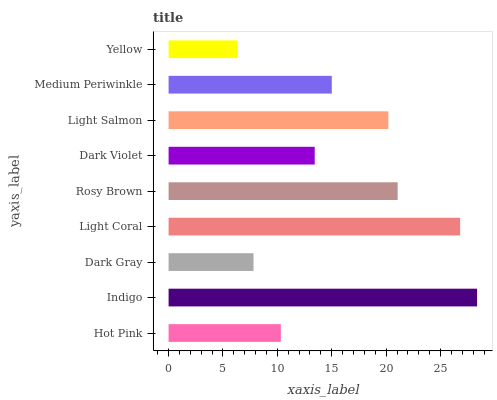Is Yellow the minimum?
Answer yes or no. Yes. Is Indigo the maximum?
Answer yes or no. Yes. Is Dark Gray the minimum?
Answer yes or no. No. Is Dark Gray the maximum?
Answer yes or no. No. Is Indigo greater than Dark Gray?
Answer yes or no. Yes. Is Dark Gray less than Indigo?
Answer yes or no. Yes. Is Dark Gray greater than Indigo?
Answer yes or no. No. Is Indigo less than Dark Gray?
Answer yes or no. No. Is Medium Periwinkle the high median?
Answer yes or no. Yes. Is Medium Periwinkle the low median?
Answer yes or no. Yes. Is Indigo the high median?
Answer yes or no. No. Is Rosy Brown the low median?
Answer yes or no. No. 